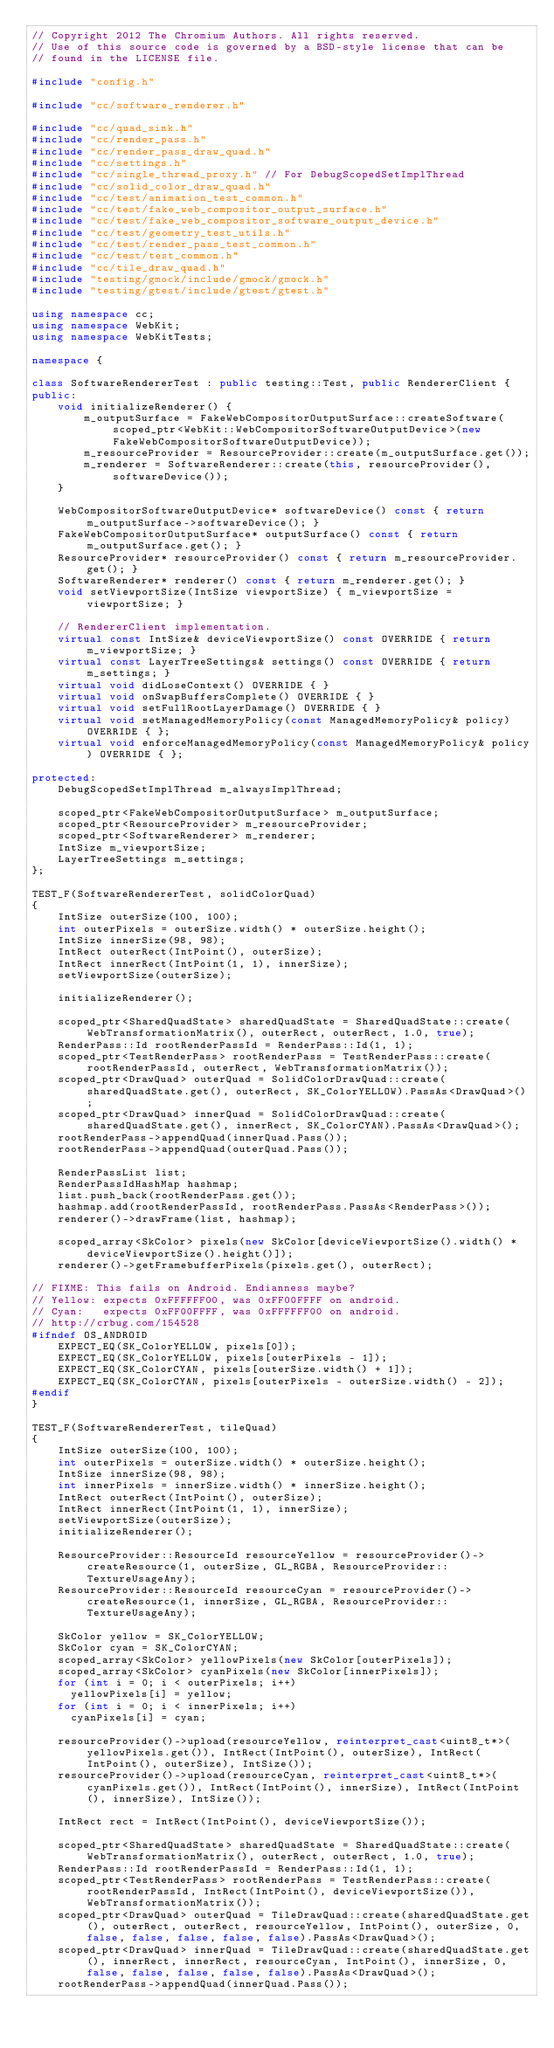<code> <loc_0><loc_0><loc_500><loc_500><_C++_>// Copyright 2012 The Chromium Authors. All rights reserved.
// Use of this source code is governed by a BSD-style license that can be
// found in the LICENSE file.

#include "config.h"

#include "cc/software_renderer.h"

#include "cc/quad_sink.h"
#include "cc/render_pass.h"
#include "cc/render_pass_draw_quad.h"
#include "cc/settings.h"
#include "cc/single_thread_proxy.h" // For DebugScopedSetImplThread
#include "cc/solid_color_draw_quad.h"
#include "cc/test/animation_test_common.h"
#include "cc/test/fake_web_compositor_output_surface.h"
#include "cc/test/fake_web_compositor_software_output_device.h"
#include "cc/test/geometry_test_utils.h"
#include "cc/test/render_pass_test_common.h"
#include "cc/test/test_common.h"
#include "cc/tile_draw_quad.h"
#include "testing/gmock/include/gmock/gmock.h"
#include "testing/gtest/include/gtest/gtest.h"

using namespace cc;
using namespace WebKit;
using namespace WebKitTests;

namespace {

class SoftwareRendererTest : public testing::Test, public RendererClient {
public:
    void initializeRenderer() {
        m_outputSurface = FakeWebCompositorOutputSurface::createSoftware(scoped_ptr<WebKit::WebCompositorSoftwareOutputDevice>(new FakeWebCompositorSoftwareOutputDevice));
        m_resourceProvider = ResourceProvider::create(m_outputSurface.get());
        m_renderer = SoftwareRenderer::create(this, resourceProvider(), softwareDevice());
    }

    WebCompositorSoftwareOutputDevice* softwareDevice() const { return m_outputSurface->softwareDevice(); }
    FakeWebCompositorOutputSurface* outputSurface() const { return m_outputSurface.get(); }
    ResourceProvider* resourceProvider() const { return m_resourceProvider.get(); }
    SoftwareRenderer* renderer() const { return m_renderer.get(); }
    void setViewportSize(IntSize viewportSize) { m_viewportSize = viewportSize; }

    // RendererClient implementation.
    virtual const IntSize& deviceViewportSize() const OVERRIDE { return m_viewportSize; }
    virtual const LayerTreeSettings& settings() const OVERRIDE { return m_settings; }
    virtual void didLoseContext() OVERRIDE { }
    virtual void onSwapBuffersComplete() OVERRIDE { }
    virtual void setFullRootLayerDamage() OVERRIDE { }
    virtual void setManagedMemoryPolicy(const ManagedMemoryPolicy& policy) OVERRIDE { };
    virtual void enforceManagedMemoryPolicy(const ManagedMemoryPolicy& policy) OVERRIDE { };

protected:
    DebugScopedSetImplThread m_alwaysImplThread;

    scoped_ptr<FakeWebCompositorOutputSurface> m_outputSurface;
    scoped_ptr<ResourceProvider> m_resourceProvider;
    scoped_ptr<SoftwareRenderer> m_renderer;
    IntSize m_viewportSize;
    LayerTreeSettings m_settings;
};

TEST_F(SoftwareRendererTest, solidColorQuad)
{
    IntSize outerSize(100, 100);
    int outerPixels = outerSize.width() * outerSize.height();
    IntSize innerSize(98, 98);
    IntRect outerRect(IntPoint(), outerSize);
    IntRect innerRect(IntPoint(1, 1), innerSize);
    setViewportSize(outerSize);

    initializeRenderer();

    scoped_ptr<SharedQuadState> sharedQuadState = SharedQuadState::create(WebTransformationMatrix(), outerRect, outerRect, 1.0, true);
    RenderPass::Id rootRenderPassId = RenderPass::Id(1, 1);
    scoped_ptr<TestRenderPass> rootRenderPass = TestRenderPass::create(rootRenderPassId, outerRect, WebTransformationMatrix());
    scoped_ptr<DrawQuad> outerQuad = SolidColorDrawQuad::create(sharedQuadState.get(), outerRect, SK_ColorYELLOW).PassAs<DrawQuad>();
    scoped_ptr<DrawQuad> innerQuad = SolidColorDrawQuad::create(sharedQuadState.get(), innerRect, SK_ColorCYAN).PassAs<DrawQuad>();
    rootRenderPass->appendQuad(innerQuad.Pass());
    rootRenderPass->appendQuad(outerQuad.Pass());

    RenderPassList list;
    RenderPassIdHashMap hashmap;
    list.push_back(rootRenderPass.get());
    hashmap.add(rootRenderPassId, rootRenderPass.PassAs<RenderPass>());
    renderer()->drawFrame(list, hashmap);

    scoped_array<SkColor> pixels(new SkColor[deviceViewportSize().width() * deviceViewportSize().height()]);
    renderer()->getFramebufferPixels(pixels.get(), outerRect);

// FIXME: This fails on Android. Endianness maybe?
// Yellow: expects 0xFFFFFF00, was 0xFF00FFFF on android.
// Cyan:   expects 0xFF00FFFF, was 0xFFFFFF00 on android.
// http://crbug.com/154528
#ifndef OS_ANDROID
    EXPECT_EQ(SK_ColorYELLOW, pixels[0]);
    EXPECT_EQ(SK_ColorYELLOW, pixels[outerPixels - 1]);
    EXPECT_EQ(SK_ColorCYAN, pixels[outerSize.width() + 1]);
    EXPECT_EQ(SK_ColorCYAN, pixels[outerPixels - outerSize.width() - 2]);
#endif
}

TEST_F(SoftwareRendererTest, tileQuad)
{
    IntSize outerSize(100, 100);
    int outerPixels = outerSize.width() * outerSize.height();
    IntSize innerSize(98, 98);
    int innerPixels = innerSize.width() * innerSize.height();
    IntRect outerRect(IntPoint(), outerSize);
    IntRect innerRect(IntPoint(1, 1), innerSize);
    setViewportSize(outerSize);
    initializeRenderer();

    ResourceProvider::ResourceId resourceYellow = resourceProvider()->createResource(1, outerSize, GL_RGBA, ResourceProvider::TextureUsageAny);
    ResourceProvider::ResourceId resourceCyan = resourceProvider()->createResource(1, innerSize, GL_RGBA, ResourceProvider::TextureUsageAny);

    SkColor yellow = SK_ColorYELLOW;
    SkColor cyan = SK_ColorCYAN;
    scoped_array<SkColor> yellowPixels(new SkColor[outerPixels]);
    scoped_array<SkColor> cyanPixels(new SkColor[innerPixels]);
    for (int i = 0; i < outerPixels; i++)
      yellowPixels[i] = yellow;
    for (int i = 0; i < innerPixels; i++)
      cyanPixels[i] = cyan;

    resourceProvider()->upload(resourceYellow, reinterpret_cast<uint8_t*>(yellowPixels.get()), IntRect(IntPoint(), outerSize), IntRect(IntPoint(), outerSize), IntSize());
    resourceProvider()->upload(resourceCyan, reinterpret_cast<uint8_t*>(cyanPixels.get()), IntRect(IntPoint(), innerSize), IntRect(IntPoint(), innerSize), IntSize());

    IntRect rect = IntRect(IntPoint(), deviceViewportSize());

    scoped_ptr<SharedQuadState> sharedQuadState = SharedQuadState::create(WebTransformationMatrix(), outerRect, outerRect, 1.0, true);
    RenderPass::Id rootRenderPassId = RenderPass::Id(1, 1);
    scoped_ptr<TestRenderPass> rootRenderPass = TestRenderPass::create(rootRenderPassId, IntRect(IntPoint(), deviceViewportSize()), WebTransformationMatrix());
    scoped_ptr<DrawQuad> outerQuad = TileDrawQuad::create(sharedQuadState.get(), outerRect, outerRect, resourceYellow, IntPoint(), outerSize, 0, false, false, false, false, false).PassAs<DrawQuad>();
    scoped_ptr<DrawQuad> innerQuad = TileDrawQuad::create(sharedQuadState.get(), innerRect, innerRect, resourceCyan, IntPoint(), innerSize, 0, false, false, false, false, false).PassAs<DrawQuad>();
    rootRenderPass->appendQuad(innerQuad.Pass());</code> 